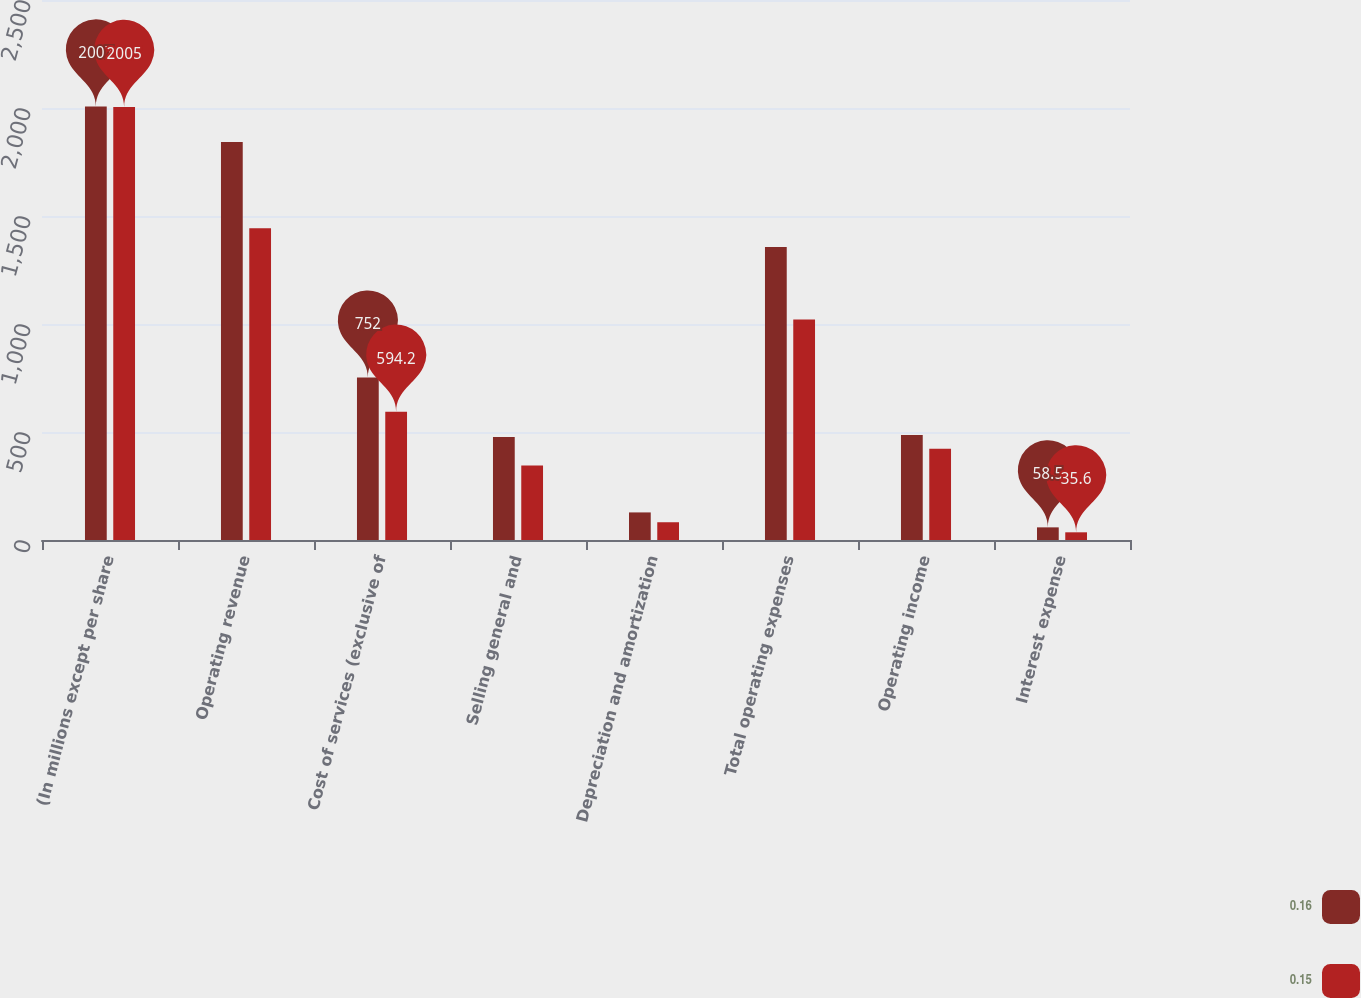Convert chart to OTSL. <chart><loc_0><loc_0><loc_500><loc_500><stacked_bar_chart><ecel><fcel>(In millions except per share<fcel>Operating revenue<fcel>Cost of services (exclusive of<fcel>Selling general and<fcel>Depreciation and amortization<fcel>Total operating expenses<fcel>Operating income<fcel>Interest expense<nl><fcel>0.16<fcel>2007<fcel>1843<fcel>752<fcel>477.1<fcel>127.7<fcel>1356.8<fcel>486.2<fcel>58.5<nl><fcel>0.15<fcel>2005<fcel>1443.4<fcel>594.2<fcel>345<fcel>82.2<fcel>1021.4<fcel>422<fcel>35.6<nl></chart> 